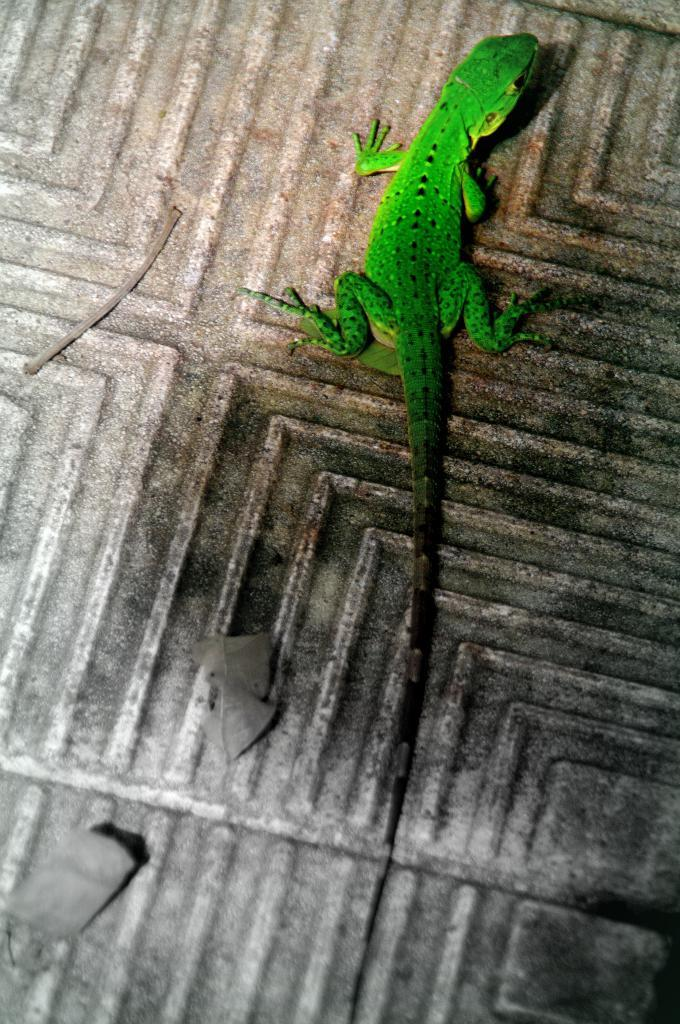What type of animal is in the image? There is a reptile in the image. Where is the reptile located in the image? The reptile is on the floor. What type of nerve can be seen in the image? There is no nerve present in the image; it features a reptile on the floor. How many times is the fabric folded in the image? There is no fabric or folding present in the image. 